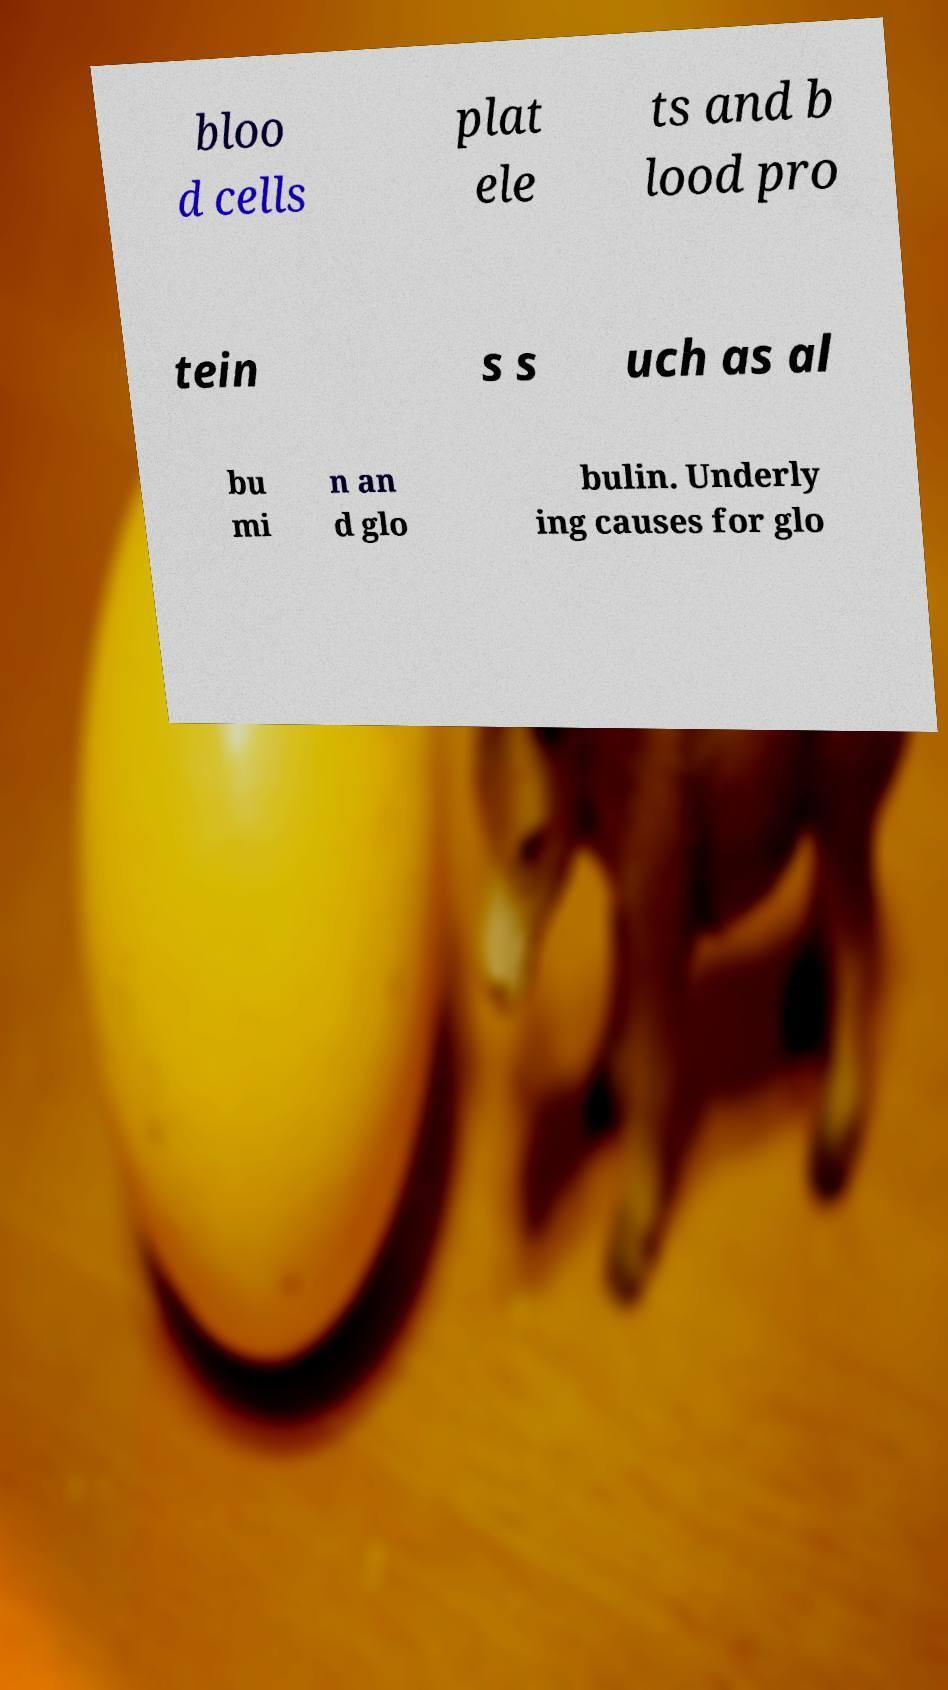Could you extract and type out the text from this image? bloo d cells plat ele ts and b lood pro tein s s uch as al bu mi n an d glo bulin. Underly ing causes for glo 